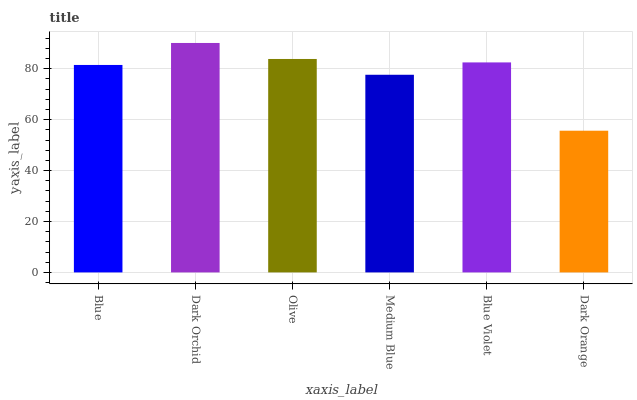Is Dark Orange the minimum?
Answer yes or no. Yes. Is Dark Orchid the maximum?
Answer yes or no. Yes. Is Olive the minimum?
Answer yes or no. No. Is Olive the maximum?
Answer yes or no. No. Is Dark Orchid greater than Olive?
Answer yes or no. Yes. Is Olive less than Dark Orchid?
Answer yes or no. Yes. Is Olive greater than Dark Orchid?
Answer yes or no. No. Is Dark Orchid less than Olive?
Answer yes or no. No. Is Blue Violet the high median?
Answer yes or no. Yes. Is Blue the low median?
Answer yes or no. Yes. Is Olive the high median?
Answer yes or no. No. Is Dark Orange the low median?
Answer yes or no. No. 